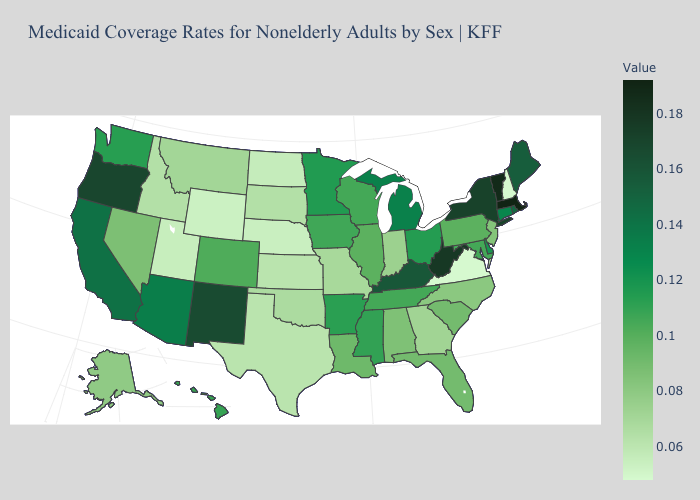Does Massachusetts have the highest value in the Northeast?
Write a very short answer. Yes. Does West Virginia have a lower value than North Carolina?
Keep it brief. No. Among the states that border Oregon , which have the highest value?
Short answer required. California. 